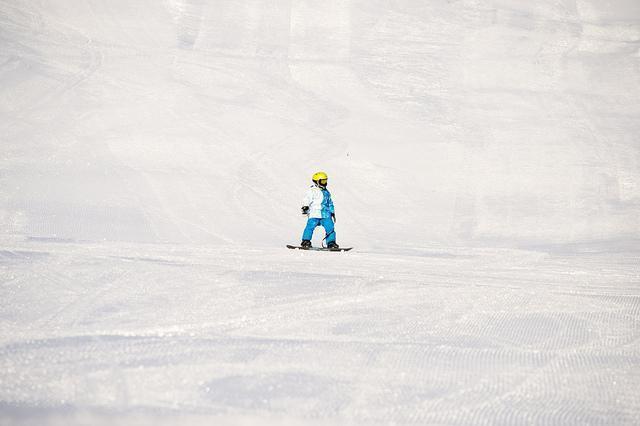How many people are shown?
Give a very brief answer. 1. How many people are wearing a hat?
Give a very brief answer. 1. How many chairs in this image have visible legs?
Give a very brief answer. 0. 